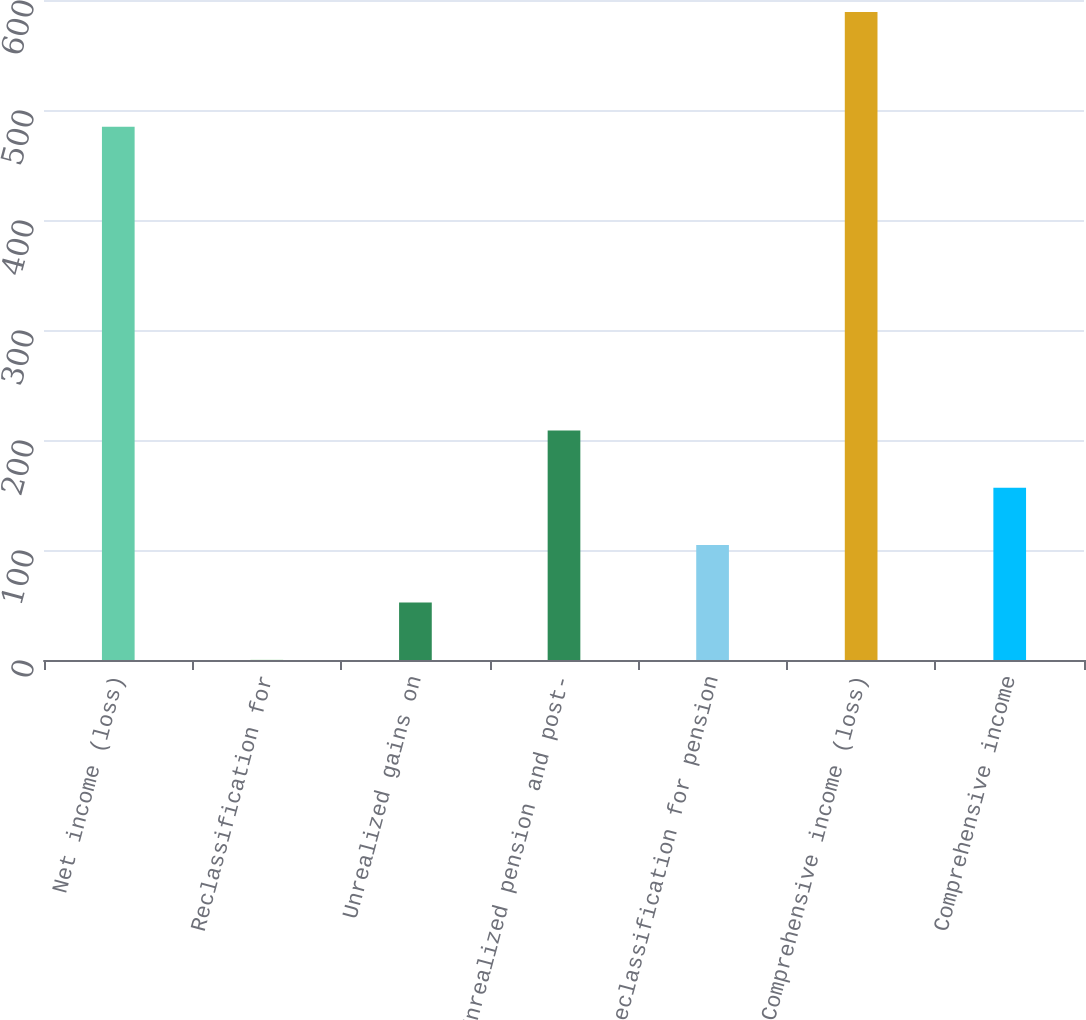Convert chart. <chart><loc_0><loc_0><loc_500><loc_500><bar_chart><fcel>Net income (loss)<fcel>Reclassification for<fcel>Unrealized gains on<fcel>Unrealized pension and post-<fcel>Reclassification for pension<fcel>Comprehensive income (loss)<fcel>Comprehensive income<nl><fcel>484.8<fcel>0.2<fcel>52.33<fcel>208.72<fcel>104.46<fcel>589.06<fcel>156.59<nl></chart> 